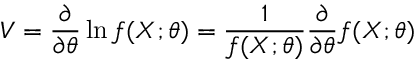Convert formula to latex. <formula><loc_0><loc_0><loc_500><loc_500>V = { \frac { \partial } { \partial \theta } } \ln f ( X ; \theta ) = { \frac { 1 } { f ( X ; \theta ) } } { \frac { \partial } { \partial \theta } } f ( X ; \theta )</formula> 